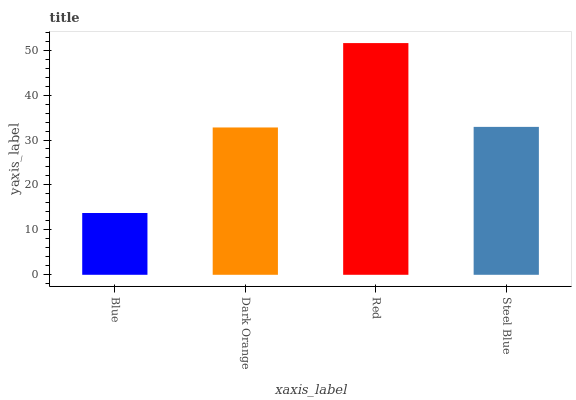Is Dark Orange the minimum?
Answer yes or no. No. Is Dark Orange the maximum?
Answer yes or no. No. Is Dark Orange greater than Blue?
Answer yes or no. Yes. Is Blue less than Dark Orange?
Answer yes or no. Yes. Is Blue greater than Dark Orange?
Answer yes or no. No. Is Dark Orange less than Blue?
Answer yes or no. No. Is Steel Blue the high median?
Answer yes or no. Yes. Is Dark Orange the low median?
Answer yes or no. Yes. Is Red the high median?
Answer yes or no. No. Is Red the low median?
Answer yes or no. No. 